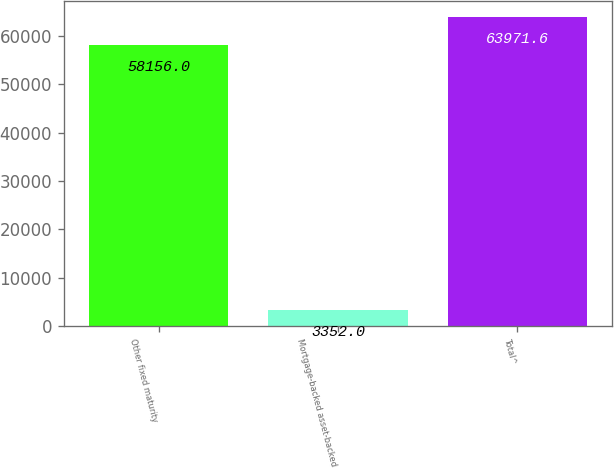<chart> <loc_0><loc_0><loc_500><loc_500><bar_chart><fcel>Other fixed maturity<fcel>Mortgage-backed asset-backed<fcel>Total^<nl><fcel>58156<fcel>3352<fcel>63971.6<nl></chart> 